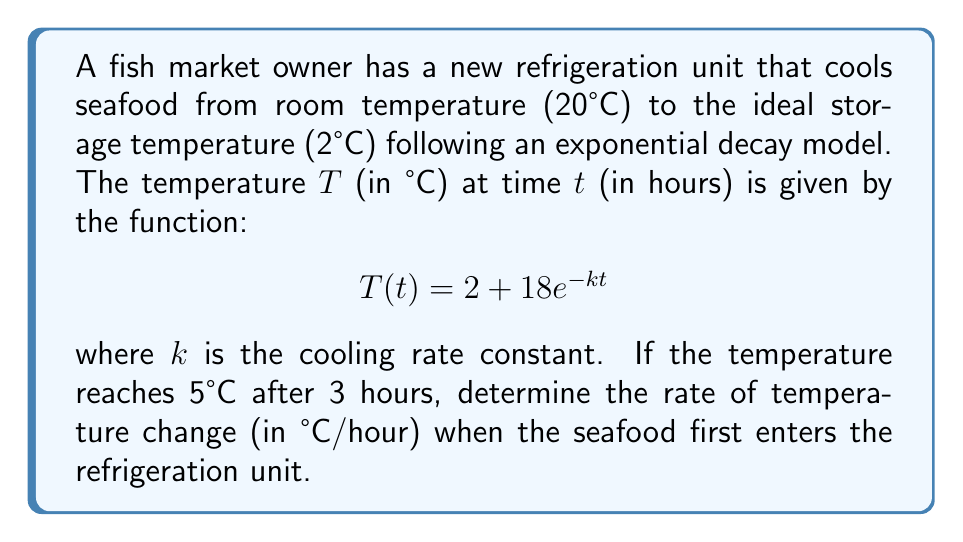Teach me how to tackle this problem. To solve this problem, we'll follow these steps:

1) First, we need to find the value of $k$ using the given information.
2) Then, we'll use the derivative of the temperature function to find the rate of change.
3) Finally, we'll evaluate the rate of change at $t=0$ (when the seafood first enters the unit).

Step 1: Finding $k$
We know that after 3 hours, the temperature is 5°C. Let's use this to solve for $k$:

$$5 = 2 + 18e^{-k(3)}$$
$$3 = 18e^{-3k}$$
$$\frac{1}{6} = e^{-3k}$$
$$\ln(\frac{1}{6}) = -3k$$
$$k = -\frac{1}{3}\ln(\frac{1}{6}) \approx 0.6015$$

Step 2: Finding the rate of change
The rate of change is given by the derivative of $T(t)$ with respect to $t$:

$$\frac{dT}{dt} = \frac{d}{dt}(2 + 18e^{-kt}) = -18ke^{-kt}$$

Step 3: Evaluating at $t=0$
When the seafood first enters the unit, $t=0$. So we evaluate the derivative at this point:

$$\left.\frac{dT}{dt}\right|_{t=0} = -18k(e^{-k(0)}) = -18k$$

Substituting our value for $k$:

$$\left.\frac{dT}{dt}\right|_{t=0} = -18(0.6015) \approx -10.827$$

The negative sign indicates that the temperature is decreasing.
Answer: The rate of temperature change when the seafood first enters the refrigeration unit is approximately -10.83°C/hour. 